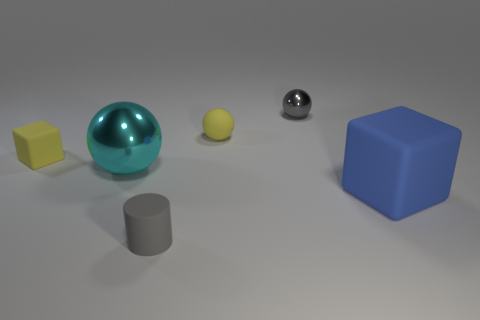The gray object that is the same shape as the large cyan shiny object is what size?
Make the answer very short. Small. What size is the ball that is the same color as the small cylinder?
Ensure brevity in your answer.  Small. Do the big blue rubber thing and the cyan object have the same shape?
Offer a terse response. No. There is a tiny gray object that is the same shape as the big cyan object; what is its material?
Your response must be concise. Metal. There is a cube that is right of the small gray cylinder; does it have the same color as the tiny matte cylinder?
Your response must be concise. No. Does the large blue thing have the same material as the yellow object that is on the right side of the gray matte cylinder?
Provide a succinct answer. Yes. There is a yellow matte object left of the big cyan ball; what shape is it?
Your answer should be compact. Cube. How many other objects are the same material as the cyan ball?
Offer a very short reply. 1. What size is the cylinder?
Offer a terse response. Small. How many other objects are the same color as the big metallic sphere?
Provide a succinct answer. 0. 